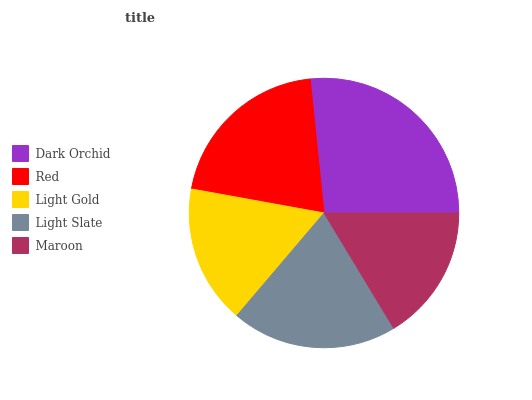Is Maroon the minimum?
Answer yes or no. Yes. Is Dark Orchid the maximum?
Answer yes or no. Yes. Is Red the minimum?
Answer yes or no. No. Is Red the maximum?
Answer yes or no. No. Is Dark Orchid greater than Red?
Answer yes or no. Yes. Is Red less than Dark Orchid?
Answer yes or no. Yes. Is Red greater than Dark Orchid?
Answer yes or no. No. Is Dark Orchid less than Red?
Answer yes or no. No. Is Light Slate the high median?
Answer yes or no. Yes. Is Light Slate the low median?
Answer yes or no. Yes. Is Dark Orchid the high median?
Answer yes or no. No. Is Dark Orchid the low median?
Answer yes or no. No. 